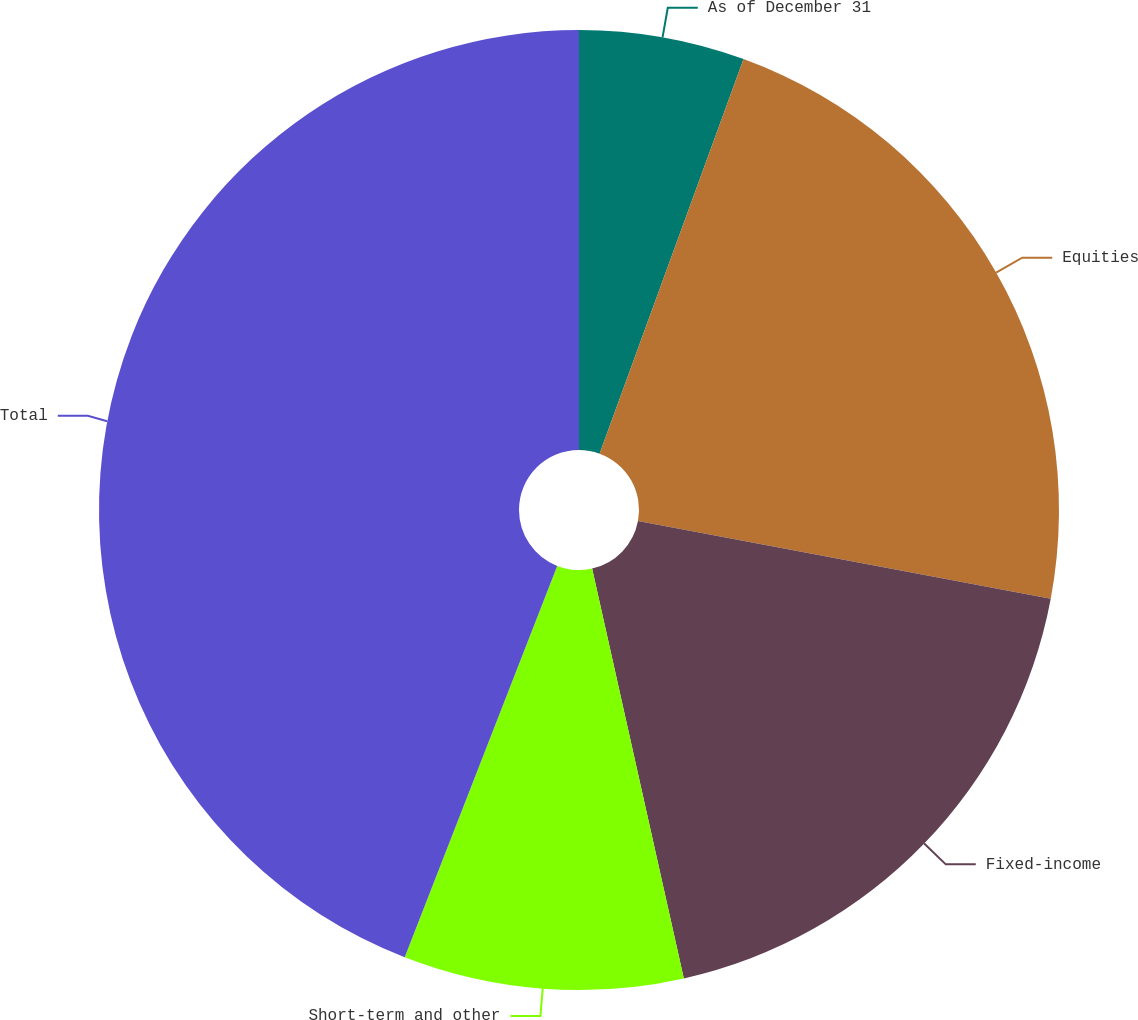Convert chart to OTSL. <chart><loc_0><loc_0><loc_500><loc_500><pie_chart><fcel>As of December 31<fcel>Equities<fcel>Fixed-income<fcel>Short-term and other<fcel>Total<nl><fcel>5.57%<fcel>22.39%<fcel>18.54%<fcel>9.42%<fcel>44.09%<nl></chart> 